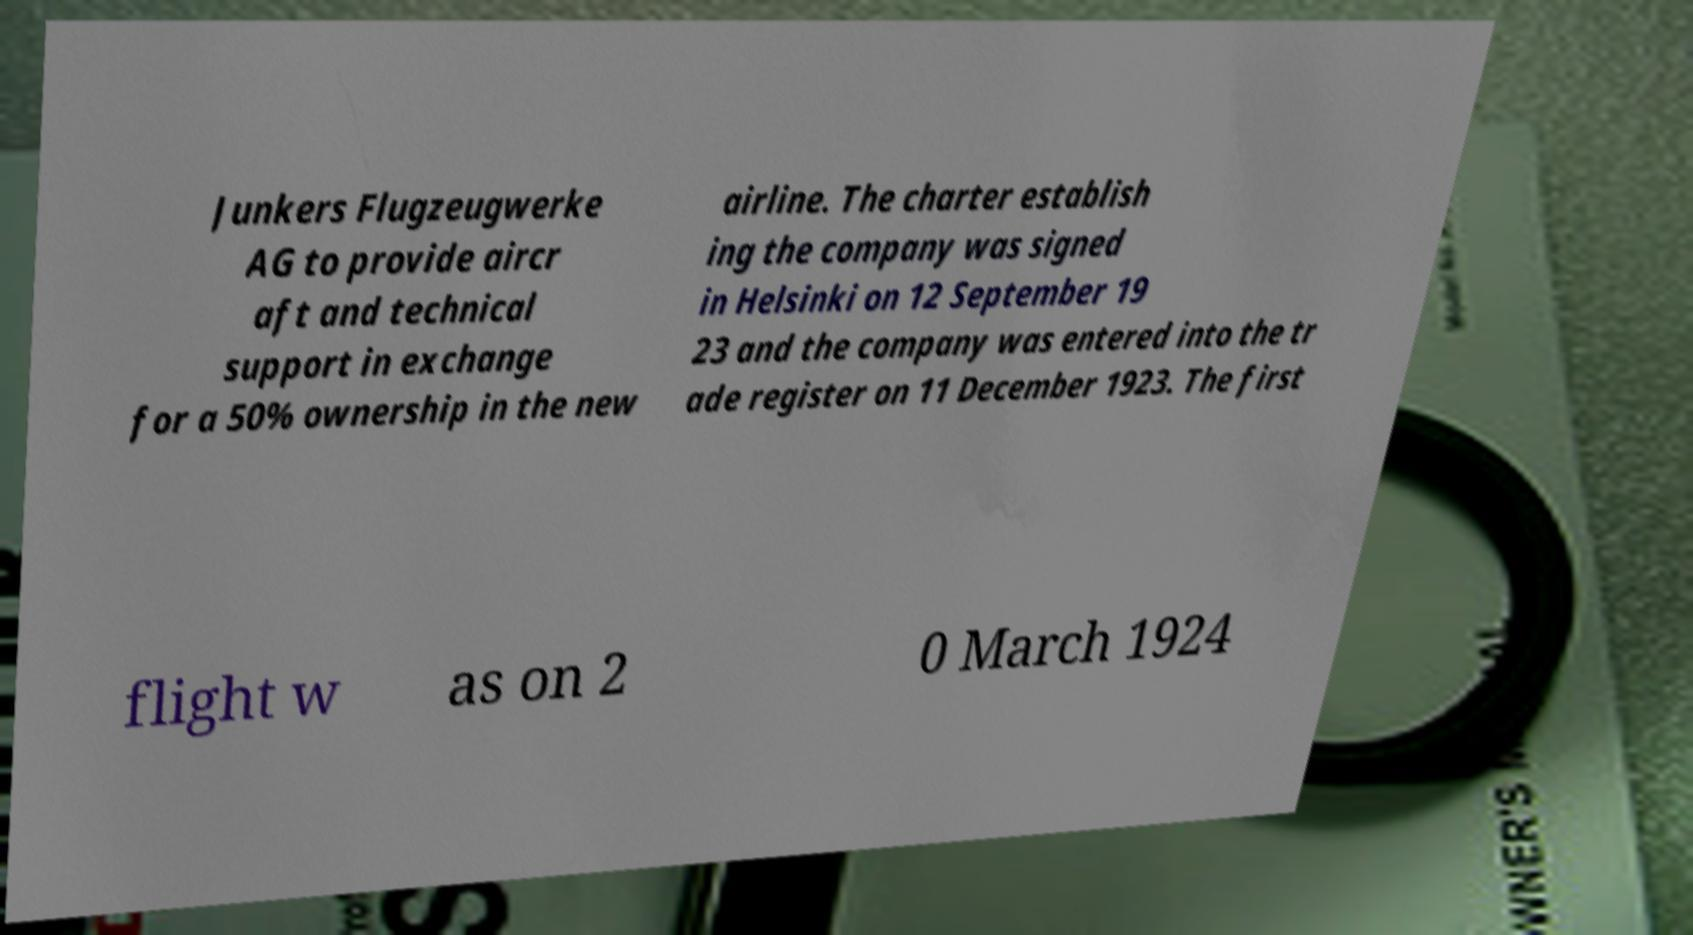Please read and relay the text visible in this image. What does it say? Junkers Flugzeugwerke AG to provide aircr aft and technical support in exchange for a 50% ownership in the new airline. The charter establish ing the company was signed in Helsinki on 12 September 19 23 and the company was entered into the tr ade register on 11 December 1923. The first flight w as on 2 0 March 1924 